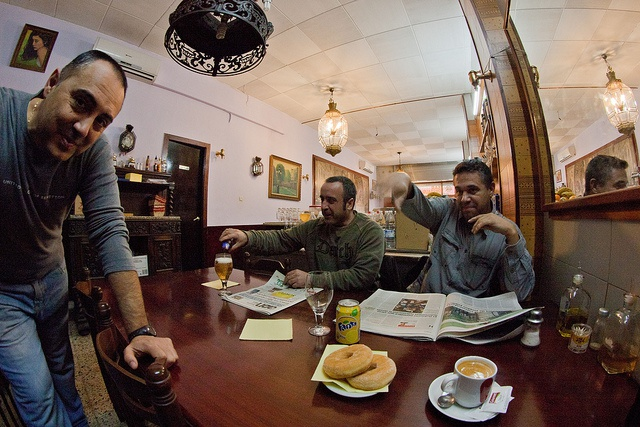Describe the objects in this image and their specific colors. I can see dining table in gray, black, maroon, and darkgray tones, people in gray, black, and navy tones, people in gray, black, and maroon tones, people in gray, black, and maroon tones, and chair in gray, black, and maroon tones in this image. 